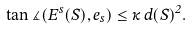<formula> <loc_0><loc_0><loc_500><loc_500>\tan \measuredangle ( E ^ { s } ( S ) , e _ { s } ) \leq \kappa \, d ( S ) ^ { 2 } .</formula> 